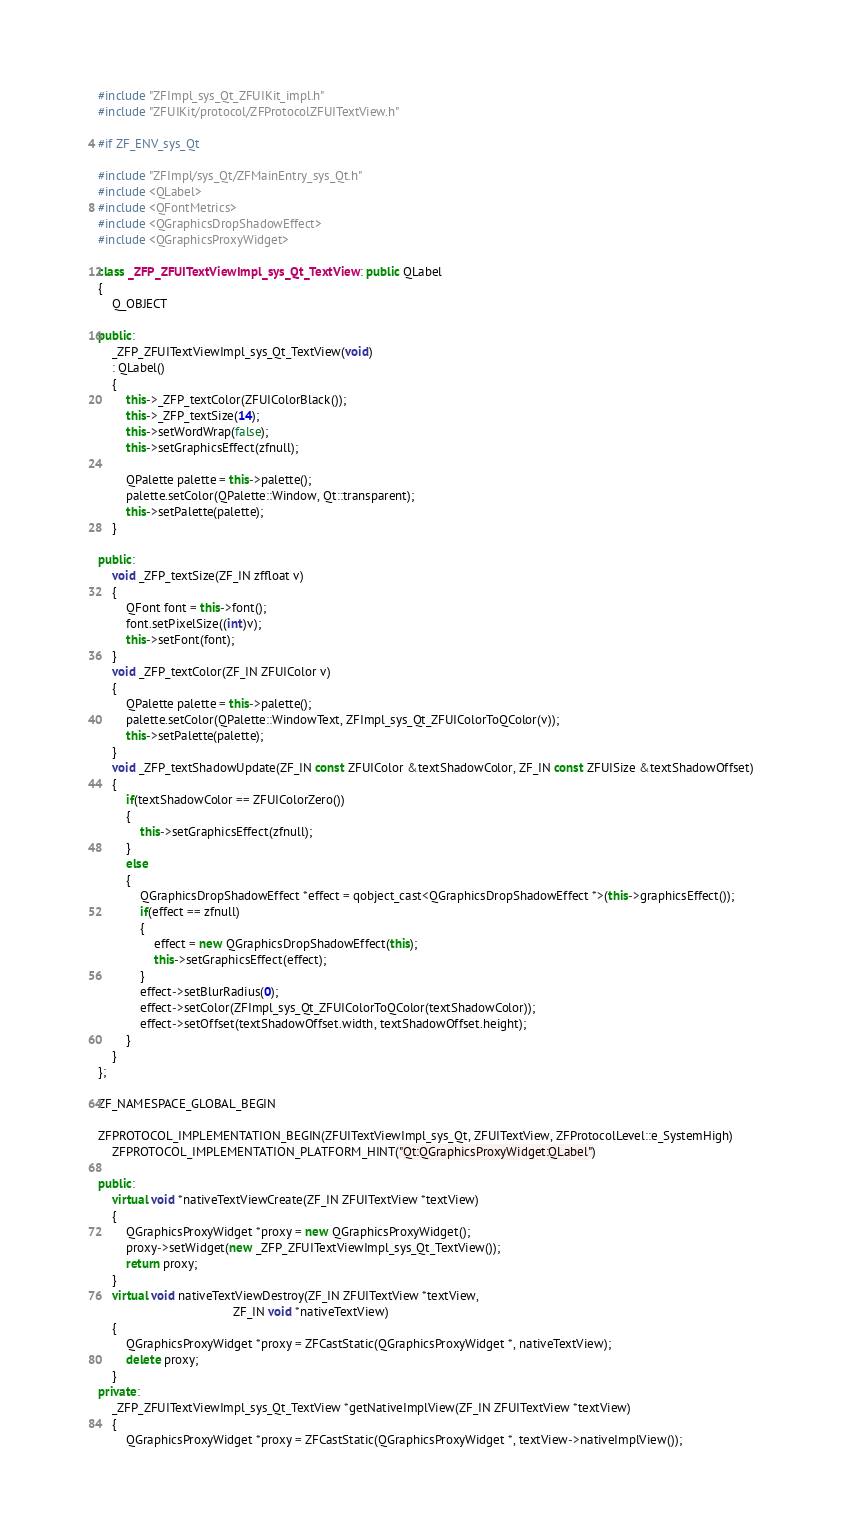Convert code to text. <code><loc_0><loc_0><loc_500><loc_500><_C++_>#include "ZFImpl_sys_Qt_ZFUIKit_impl.h"
#include "ZFUIKit/protocol/ZFProtocolZFUITextView.h"

#if ZF_ENV_sys_Qt

#include "ZFImpl/sys_Qt/ZFMainEntry_sys_Qt.h"
#include <QLabel>
#include <QFontMetrics>
#include <QGraphicsDropShadowEffect>
#include <QGraphicsProxyWidget>

class _ZFP_ZFUITextViewImpl_sys_Qt_TextView : public QLabel
{
    Q_OBJECT

public:
    _ZFP_ZFUITextViewImpl_sys_Qt_TextView(void)
    : QLabel()
    {
        this->_ZFP_textColor(ZFUIColorBlack());
        this->_ZFP_textSize(14);
        this->setWordWrap(false);
        this->setGraphicsEffect(zfnull);

        QPalette palette = this->palette();
        palette.setColor(QPalette::Window, Qt::transparent);
        this->setPalette(palette);
    }

public:
    void _ZFP_textSize(ZF_IN zffloat v)
    {
        QFont font = this->font();
        font.setPixelSize((int)v);
        this->setFont(font);
    }
    void _ZFP_textColor(ZF_IN ZFUIColor v)
    {
        QPalette palette = this->palette();
        palette.setColor(QPalette::WindowText, ZFImpl_sys_Qt_ZFUIColorToQColor(v));
        this->setPalette(palette);
    }
    void _ZFP_textShadowUpdate(ZF_IN const ZFUIColor &textShadowColor, ZF_IN const ZFUISize &textShadowOffset)
    {
        if(textShadowColor == ZFUIColorZero())
        {
            this->setGraphicsEffect(zfnull);
        }
        else
        {
            QGraphicsDropShadowEffect *effect = qobject_cast<QGraphicsDropShadowEffect *>(this->graphicsEffect());
            if(effect == zfnull)
            {
                effect = new QGraphicsDropShadowEffect(this);
                this->setGraphicsEffect(effect);
            }
            effect->setBlurRadius(0);
            effect->setColor(ZFImpl_sys_Qt_ZFUIColorToQColor(textShadowColor));
            effect->setOffset(textShadowOffset.width, textShadowOffset.height);
        }
    }
};

ZF_NAMESPACE_GLOBAL_BEGIN

ZFPROTOCOL_IMPLEMENTATION_BEGIN(ZFUITextViewImpl_sys_Qt, ZFUITextView, ZFProtocolLevel::e_SystemHigh)
    ZFPROTOCOL_IMPLEMENTATION_PLATFORM_HINT("Qt:QGraphicsProxyWidget:QLabel")

public:
    virtual void *nativeTextViewCreate(ZF_IN ZFUITextView *textView)
    {
        QGraphicsProxyWidget *proxy = new QGraphicsProxyWidget();
        proxy->setWidget(new _ZFP_ZFUITextViewImpl_sys_Qt_TextView());
        return proxy;
    }
    virtual void nativeTextViewDestroy(ZF_IN ZFUITextView *textView,
                                       ZF_IN void *nativeTextView)
    {
        QGraphicsProxyWidget *proxy = ZFCastStatic(QGraphicsProxyWidget *, nativeTextView);
        delete proxy;
    }
private:
    _ZFP_ZFUITextViewImpl_sys_Qt_TextView *getNativeImplView(ZF_IN ZFUITextView *textView)
    {
        QGraphicsProxyWidget *proxy = ZFCastStatic(QGraphicsProxyWidget *, textView->nativeImplView());</code> 